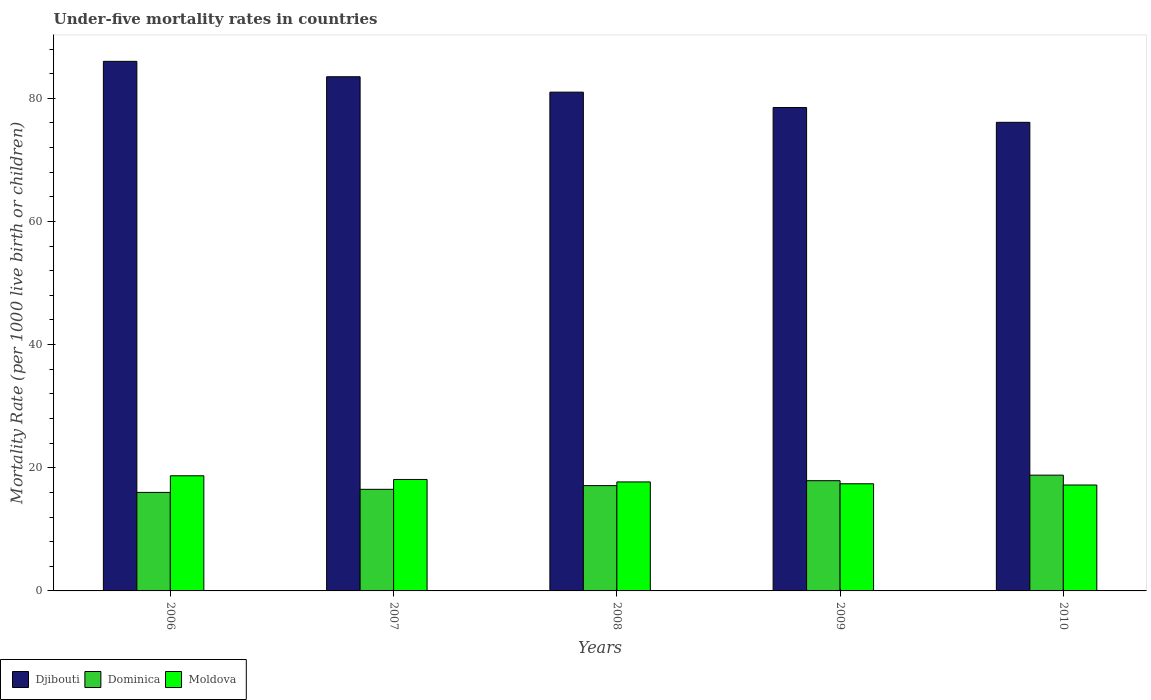Are the number of bars on each tick of the X-axis equal?
Offer a terse response. Yes. How many bars are there on the 2nd tick from the left?
Your answer should be very brief. 3. In how many cases, is the number of bars for a given year not equal to the number of legend labels?
Keep it short and to the point. 0. What is the under-five mortality rate in Dominica in 2009?
Ensure brevity in your answer.  17.9. Across all years, what is the maximum under-five mortality rate in Moldova?
Your answer should be very brief. 18.7. What is the total under-five mortality rate in Djibouti in the graph?
Make the answer very short. 405.1. What is the difference between the under-five mortality rate in Moldova in 2010 and the under-five mortality rate in Djibouti in 2009?
Your response must be concise. -61.3. What is the average under-five mortality rate in Djibouti per year?
Offer a very short reply. 81.02. What is the ratio of the under-five mortality rate in Dominica in 2007 to that in 2008?
Make the answer very short. 0.96. What is the difference between the highest and the lowest under-five mortality rate in Dominica?
Offer a terse response. 2.8. What does the 1st bar from the left in 2006 represents?
Keep it short and to the point. Djibouti. What does the 1st bar from the right in 2010 represents?
Offer a terse response. Moldova. Are all the bars in the graph horizontal?
Ensure brevity in your answer.  No. How many years are there in the graph?
Your answer should be very brief. 5. What is the difference between two consecutive major ticks on the Y-axis?
Keep it short and to the point. 20. Does the graph contain grids?
Ensure brevity in your answer.  No. How many legend labels are there?
Your answer should be compact. 3. How are the legend labels stacked?
Offer a terse response. Horizontal. What is the title of the graph?
Offer a terse response. Under-five mortality rates in countries. Does "Myanmar" appear as one of the legend labels in the graph?
Make the answer very short. No. What is the label or title of the X-axis?
Offer a very short reply. Years. What is the label or title of the Y-axis?
Provide a short and direct response. Mortality Rate (per 1000 live birth or children). What is the Mortality Rate (per 1000 live birth or children) of Djibouti in 2006?
Offer a very short reply. 86. What is the Mortality Rate (per 1000 live birth or children) of Djibouti in 2007?
Provide a succinct answer. 83.5. What is the Mortality Rate (per 1000 live birth or children) in Dominica in 2007?
Offer a very short reply. 16.5. What is the Mortality Rate (per 1000 live birth or children) of Djibouti in 2008?
Provide a short and direct response. 81. What is the Mortality Rate (per 1000 live birth or children) of Dominica in 2008?
Your answer should be compact. 17.1. What is the Mortality Rate (per 1000 live birth or children) in Djibouti in 2009?
Give a very brief answer. 78.5. What is the Mortality Rate (per 1000 live birth or children) of Moldova in 2009?
Ensure brevity in your answer.  17.4. What is the Mortality Rate (per 1000 live birth or children) of Djibouti in 2010?
Offer a terse response. 76.1. Across all years, what is the maximum Mortality Rate (per 1000 live birth or children) of Djibouti?
Your response must be concise. 86. Across all years, what is the minimum Mortality Rate (per 1000 live birth or children) of Djibouti?
Offer a terse response. 76.1. Across all years, what is the minimum Mortality Rate (per 1000 live birth or children) in Dominica?
Ensure brevity in your answer.  16. Across all years, what is the minimum Mortality Rate (per 1000 live birth or children) in Moldova?
Offer a very short reply. 17.2. What is the total Mortality Rate (per 1000 live birth or children) in Djibouti in the graph?
Make the answer very short. 405.1. What is the total Mortality Rate (per 1000 live birth or children) in Dominica in the graph?
Offer a terse response. 86.3. What is the total Mortality Rate (per 1000 live birth or children) of Moldova in the graph?
Offer a very short reply. 89.1. What is the difference between the Mortality Rate (per 1000 live birth or children) of Djibouti in 2006 and that in 2007?
Provide a short and direct response. 2.5. What is the difference between the Mortality Rate (per 1000 live birth or children) in Djibouti in 2006 and that in 2008?
Your answer should be compact. 5. What is the difference between the Mortality Rate (per 1000 live birth or children) of Moldova in 2006 and that in 2008?
Make the answer very short. 1. What is the difference between the Mortality Rate (per 1000 live birth or children) in Djibouti in 2006 and that in 2009?
Keep it short and to the point. 7.5. What is the difference between the Mortality Rate (per 1000 live birth or children) of Moldova in 2006 and that in 2009?
Your answer should be very brief. 1.3. What is the difference between the Mortality Rate (per 1000 live birth or children) in Dominica in 2007 and that in 2008?
Provide a short and direct response. -0.6. What is the difference between the Mortality Rate (per 1000 live birth or children) in Moldova in 2007 and that in 2008?
Offer a very short reply. 0.4. What is the difference between the Mortality Rate (per 1000 live birth or children) of Djibouti in 2007 and that in 2009?
Your response must be concise. 5. What is the difference between the Mortality Rate (per 1000 live birth or children) of Moldova in 2007 and that in 2009?
Make the answer very short. 0.7. What is the difference between the Mortality Rate (per 1000 live birth or children) in Moldova in 2007 and that in 2010?
Offer a terse response. 0.9. What is the difference between the Mortality Rate (per 1000 live birth or children) of Djibouti in 2008 and that in 2009?
Make the answer very short. 2.5. What is the difference between the Mortality Rate (per 1000 live birth or children) of Dominica in 2008 and that in 2009?
Your answer should be very brief. -0.8. What is the difference between the Mortality Rate (per 1000 live birth or children) in Moldova in 2008 and that in 2009?
Make the answer very short. 0.3. What is the difference between the Mortality Rate (per 1000 live birth or children) of Djibouti in 2008 and that in 2010?
Your answer should be very brief. 4.9. What is the difference between the Mortality Rate (per 1000 live birth or children) of Moldova in 2008 and that in 2010?
Your answer should be very brief. 0.5. What is the difference between the Mortality Rate (per 1000 live birth or children) in Moldova in 2009 and that in 2010?
Keep it short and to the point. 0.2. What is the difference between the Mortality Rate (per 1000 live birth or children) in Djibouti in 2006 and the Mortality Rate (per 1000 live birth or children) in Dominica in 2007?
Your response must be concise. 69.5. What is the difference between the Mortality Rate (per 1000 live birth or children) in Djibouti in 2006 and the Mortality Rate (per 1000 live birth or children) in Moldova in 2007?
Provide a short and direct response. 67.9. What is the difference between the Mortality Rate (per 1000 live birth or children) in Dominica in 2006 and the Mortality Rate (per 1000 live birth or children) in Moldova in 2007?
Offer a terse response. -2.1. What is the difference between the Mortality Rate (per 1000 live birth or children) of Djibouti in 2006 and the Mortality Rate (per 1000 live birth or children) of Dominica in 2008?
Your answer should be compact. 68.9. What is the difference between the Mortality Rate (per 1000 live birth or children) of Djibouti in 2006 and the Mortality Rate (per 1000 live birth or children) of Moldova in 2008?
Give a very brief answer. 68.3. What is the difference between the Mortality Rate (per 1000 live birth or children) in Dominica in 2006 and the Mortality Rate (per 1000 live birth or children) in Moldova in 2008?
Keep it short and to the point. -1.7. What is the difference between the Mortality Rate (per 1000 live birth or children) in Djibouti in 2006 and the Mortality Rate (per 1000 live birth or children) in Dominica in 2009?
Your answer should be compact. 68.1. What is the difference between the Mortality Rate (per 1000 live birth or children) in Djibouti in 2006 and the Mortality Rate (per 1000 live birth or children) in Moldova in 2009?
Give a very brief answer. 68.6. What is the difference between the Mortality Rate (per 1000 live birth or children) in Djibouti in 2006 and the Mortality Rate (per 1000 live birth or children) in Dominica in 2010?
Give a very brief answer. 67.2. What is the difference between the Mortality Rate (per 1000 live birth or children) in Djibouti in 2006 and the Mortality Rate (per 1000 live birth or children) in Moldova in 2010?
Keep it short and to the point. 68.8. What is the difference between the Mortality Rate (per 1000 live birth or children) in Djibouti in 2007 and the Mortality Rate (per 1000 live birth or children) in Dominica in 2008?
Make the answer very short. 66.4. What is the difference between the Mortality Rate (per 1000 live birth or children) of Djibouti in 2007 and the Mortality Rate (per 1000 live birth or children) of Moldova in 2008?
Your answer should be very brief. 65.8. What is the difference between the Mortality Rate (per 1000 live birth or children) in Dominica in 2007 and the Mortality Rate (per 1000 live birth or children) in Moldova in 2008?
Give a very brief answer. -1.2. What is the difference between the Mortality Rate (per 1000 live birth or children) in Djibouti in 2007 and the Mortality Rate (per 1000 live birth or children) in Dominica in 2009?
Provide a succinct answer. 65.6. What is the difference between the Mortality Rate (per 1000 live birth or children) in Djibouti in 2007 and the Mortality Rate (per 1000 live birth or children) in Moldova in 2009?
Give a very brief answer. 66.1. What is the difference between the Mortality Rate (per 1000 live birth or children) of Djibouti in 2007 and the Mortality Rate (per 1000 live birth or children) of Dominica in 2010?
Your response must be concise. 64.7. What is the difference between the Mortality Rate (per 1000 live birth or children) of Djibouti in 2007 and the Mortality Rate (per 1000 live birth or children) of Moldova in 2010?
Offer a terse response. 66.3. What is the difference between the Mortality Rate (per 1000 live birth or children) of Dominica in 2007 and the Mortality Rate (per 1000 live birth or children) of Moldova in 2010?
Ensure brevity in your answer.  -0.7. What is the difference between the Mortality Rate (per 1000 live birth or children) of Djibouti in 2008 and the Mortality Rate (per 1000 live birth or children) of Dominica in 2009?
Offer a terse response. 63.1. What is the difference between the Mortality Rate (per 1000 live birth or children) of Djibouti in 2008 and the Mortality Rate (per 1000 live birth or children) of Moldova in 2009?
Your answer should be compact. 63.6. What is the difference between the Mortality Rate (per 1000 live birth or children) of Dominica in 2008 and the Mortality Rate (per 1000 live birth or children) of Moldova in 2009?
Make the answer very short. -0.3. What is the difference between the Mortality Rate (per 1000 live birth or children) of Djibouti in 2008 and the Mortality Rate (per 1000 live birth or children) of Dominica in 2010?
Ensure brevity in your answer.  62.2. What is the difference between the Mortality Rate (per 1000 live birth or children) of Djibouti in 2008 and the Mortality Rate (per 1000 live birth or children) of Moldova in 2010?
Offer a very short reply. 63.8. What is the difference between the Mortality Rate (per 1000 live birth or children) of Djibouti in 2009 and the Mortality Rate (per 1000 live birth or children) of Dominica in 2010?
Offer a terse response. 59.7. What is the difference between the Mortality Rate (per 1000 live birth or children) of Djibouti in 2009 and the Mortality Rate (per 1000 live birth or children) of Moldova in 2010?
Give a very brief answer. 61.3. What is the difference between the Mortality Rate (per 1000 live birth or children) of Dominica in 2009 and the Mortality Rate (per 1000 live birth or children) of Moldova in 2010?
Give a very brief answer. 0.7. What is the average Mortality Rate (per 1000 live birth or children) in Djibouti per year?
Make the answer very short. 81.02. What is the average Mortality Rate (per 1000 live birth or children) in Dominica per year?
Provide a short and direct response. 17.26. What is the average Mortality Rate (per 1000 live birth or children) of Moldova per year?
Ensure brevity in your answer.  17.82. In the year 2006, what is the difference between the Mortality Rate (per 1000 live birth or children) in Djibouti and Mortality Rate (per 1000 live birth or children) in Dominica?
Give a very brief answer. 70. In the year 2006, what is the difference between the Mortality Rate (per 1000 live birth or children) in Djibouti and Mortality Rate (per 1000 live birth or children) in Moldova?
Provide a succinct answer. 67.3. In the year 2006, what is the difference between the Mortality Rate (per 1000 live birth or children) of Dominica and Mortality Rate (per 1000 live birth or children) of Moldova?
Provide a short and direct response. -2.7. In the year 2007, what is the difference between the Mortality Rate (per 1000 live birth or children) of Djibouti and Mortality Rate (per 1000 live birth or children) of Moldova?
Provide a succinct answer. 65.4. In the year 2008, what is the difference between the Mortality Rate (per 1000 live birth or children) in Djibouti and Mortality Rate (per 1000 live birth or children) in Dominica?
Provide a short and direct response. 63.9. In the year 2008, what is the difference between the Mortality Rate (per 1000 live birth or children) in Djibouti and Mortality Rate (per 1000 live birth or children) in Moldova?
Provide a short and direct response. 63.3. In the year 2009, what is the difference between the Mortality Rate (per 1000 live birth or children) of Djibouti and Mortality Rate (per 1000 live birth or children) of Dominica?
Offer a terse response. 60.6. In the year 2009, what is the difference between the Mortality Rate (per 1000 live birth or children) in Djibouti and Mortality Rate (per 1000 live birth or children) in Moldova?
Your answer should be compact. 61.1. In the year 2010, what is the difference between the Mortality Rate (per 1000 live birth or children) of Djibouti and Mortality Rate (per 1000 live birth or children) of Dominica?
Your response must be concise. 57.3. In the year 2010, what is the difference between the Mortality Rate (per 1000 live birth or children) in Djibouti and Mortality Rate (per 1000 live birth or children) in Moldova?
Ensure brevity in your answer.  58.9. In the year 2010, what is the difference between the Mortality Rate (per 1000 live birth or children) of Dominica and Mortality Rate (per 1000 live birth or children) of Moldova?
Your answer should be very brief. 1.6. What is the ratio of the Mortality Rate (per 1000 live birth or children) in Djibouti in 2006 to that in 2007?
Keep it short and to the point. 1.03. What is the ratio of the Mortality Rate (per 1000 live birth or children) in Dominica in 2006 to that in 2007?
Make the answer very short. 0.97. What is the ratio of the Mortality Rate (per 1000 live birth or children) of Moldova in 2006 to that in 2007?
Offer a very short reply. 1.03. What is the ratio of the Mortality Rate (per 1000 live birth or children) in Djibouti in 2006 to that in 2008?
Your response must be concise. 1.06. What is the ratio of the Mortality Rate (per 1000 live birth or children) in Dominica in 2006 to that in 2008?
Keep it short and to the point. 0.94. What is the ratio of the Mortality Rate (per 1000 live birth or children) of Moldova in 2006 to that in 2008?
Your answer should be very brief. 1.06. What is the ratio of the Mortality Rate (per 1000 live birth or children) of Djibouti in 2006 to that in 2009?
Keep it short and to the point. 1.1. What is the ratio of the Mortality Rate (per 1000 live birth or children) of Dominica in 2006 to that in 2009?
Ensure brevity in your answer.  0.89. What is the ratio of the Mortality Rate (per 1000 live birth or children) of Moldova in 2006 to that in 2009?
Your answer should be compact. 1.07. What is the ratio of the Mortality Rate (per 1000 live birth or children) of Djibouti in 2006 to that in 2010?
Your response must be concise. 1.13. What is the ratio of the Mortality Rate (per 1000 live birth or children) of Dominica in 2006 to that in 2010?
Your answer should be very brief. 0.85. What is the ratio of the Mortality Rate (per 1000 live birth or children) of Moldova in 2006 to that in 2010?
Offer a terse response. 1.09. What is the ratio of the Mortality Rate (per 1000 live birth or children) of Djibouti in 2007 to that in 2008?
Provide a succinct answer. 1.03. What is the ratio of the Mortality Rate (per 1000 live birth or children) in Dominica in 2007 to that in 2008?
Keep it short and to the point. 0.96. What is the ratio of the Mortality Rate (per 1000 live birth or children) in Moldova in 2007 to that in 2008?
Ensure brevity in your answer.  1.02. What is the ratio of the Mortality Rate (per 1000 live birth or children) of Djibouti in 2007 to that in 2009?
Give a very brief answer. 1.06. What is the ratio of the Mortality Rate (per 1000 live birth or children) in Dominica in 2007 to that in 2009?
Your answer should be compact. 0.92. What is the ratio of the Mortality Rate (per 1000 live birth or children) of Moldova in 2007 to that in 2009?
Offer a terse response. 1.04. What is the ratio of the Mortality Rate (per 1000 live birth or children) of Djibouti in 2007 to that in 2010?
Your answer should be very brief. 1.1. What is the ratio of the Mortality Rate (per 1000 live birth or children) of Dominica in 2007 to that in 2010?
Make the answer very short. 0.88. What is the ratio of the Mortality Rate (per 1000 live birth or children) of Moldova in 2007 to that in 2010?
Provide a succinct answer. 1.05. What is the ratio of the Mortality Rate (per 1000 live birth or children) in Djibouti in 2008 to that in 2009?
Offer a terse response. 1.03. What is the ratio of the Mortality Rate (per 1000 live birth or children) of Dominica in 2008 to that in 2009?
Provide a succinct answer. 0.96. What is the ratio of the Mortality Rate (per 1000 live birth or children) of Moldova in 2008 to that in 2009?
Provide a succinct answer. 1.02. What is the ratio of the Mortality Rate (per 1000 live birth or children) in Djibouti in 2008 to that in 2010?
Offer a terse response. 1.06. What is the ratio of the Mortality Rate (per 1000 live birth or children) in Dominica in 2008 to that in 2010?
Your answer should be compact. 0.91. What is the ratio of the Mortality Rate (per 1000 live birth or children) in Moldova in 2008 to that in 2010?
Offer a very short reply. 1.03. What is the ratio of the Mortality Rate (per 1000 live birth or children) of Djibouti in 2009 to that in 2010?
Ensure brevity in your answer.  1.03. What is the ratio of the Mortality Rate (per 1000 live birth or children) of Dominica in 2009 to that in 2010?
Your response must be concise. 0.95. What is the ratio of the Mortality Rate (per 1000 live birth or children) of Moldova in 2009 to that in 2010?
Your response must be concise. 1.01. What is the difference between the highest and the second highest Mortality Rate (per 1000 live birth or children) of Moldova?
Offer a terse response. 0.6. 